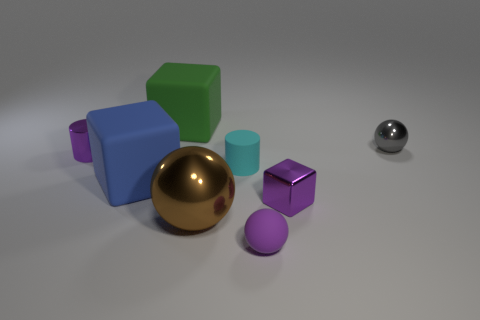Add 1 cyan cylinders. How many objects exist? 9 Subtract all blocks. How many objects are left? 5 Add 2 small cyan objects. How many small cyan objects are left? 3 Add 2 shiny balls. How many shiny balls exist? 4 Subtract 0 red cylinders. How many objects are left? 8 Subtract all big shiny balls. Subtract all small cyan things. How many objects are left? 6 